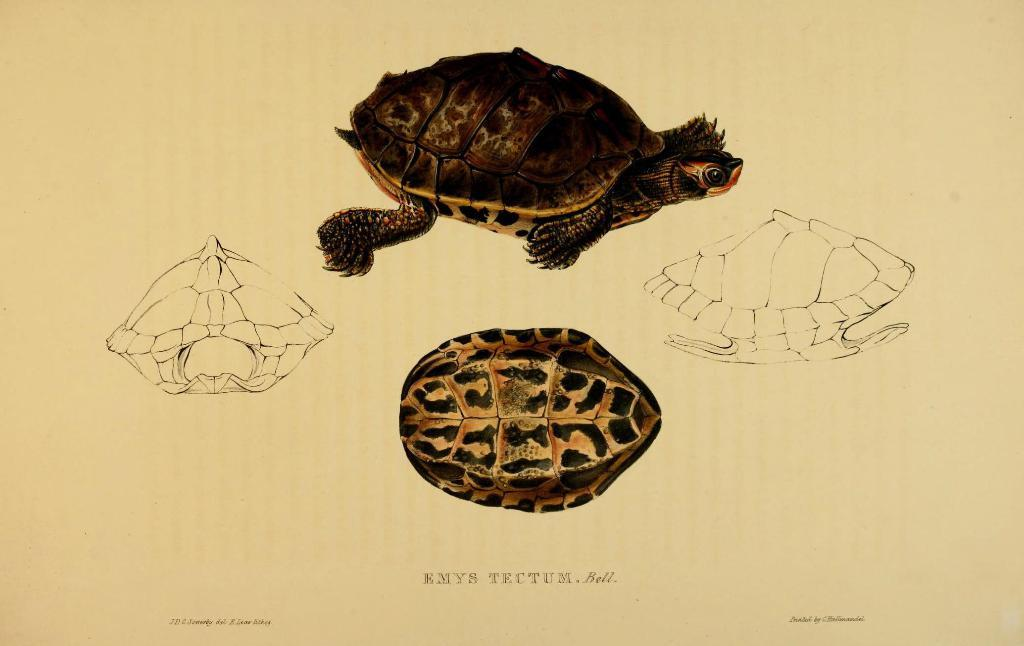What is depicted in the paintings in the image? There are paintings of a tortoise on a paper in the image. Can you describe the medium used for the paintings? The medium used for the paintings is not specified in the image, but they appear to be on paper. What type of animal is featured in the paintings? The paintings feature a tortoise. What is the price of the tortoise at the meeting in the image? There is no tortoise present in the image, nor is there any mention of a meeting or a price. 